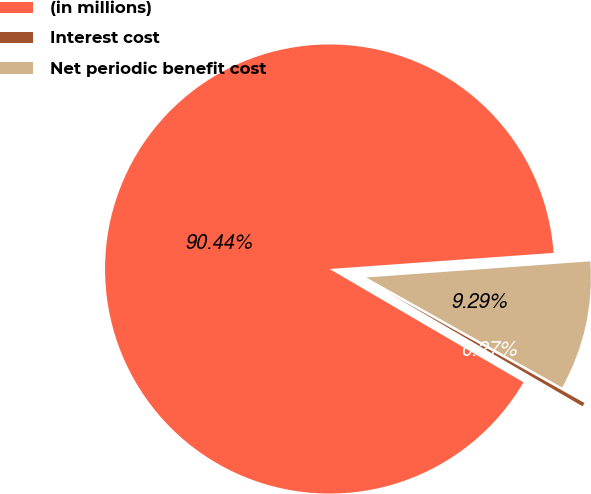Convert chart. <chart><loc_0><loc_0><loc_500><loc_500><pie_chart><fcel>(in millions)<fcel>Interest cost<fcel>Net periodic benefit cost<nl><fcel>90.44%<fcel>0.27%<fcel>9.29%<nl></chart> 